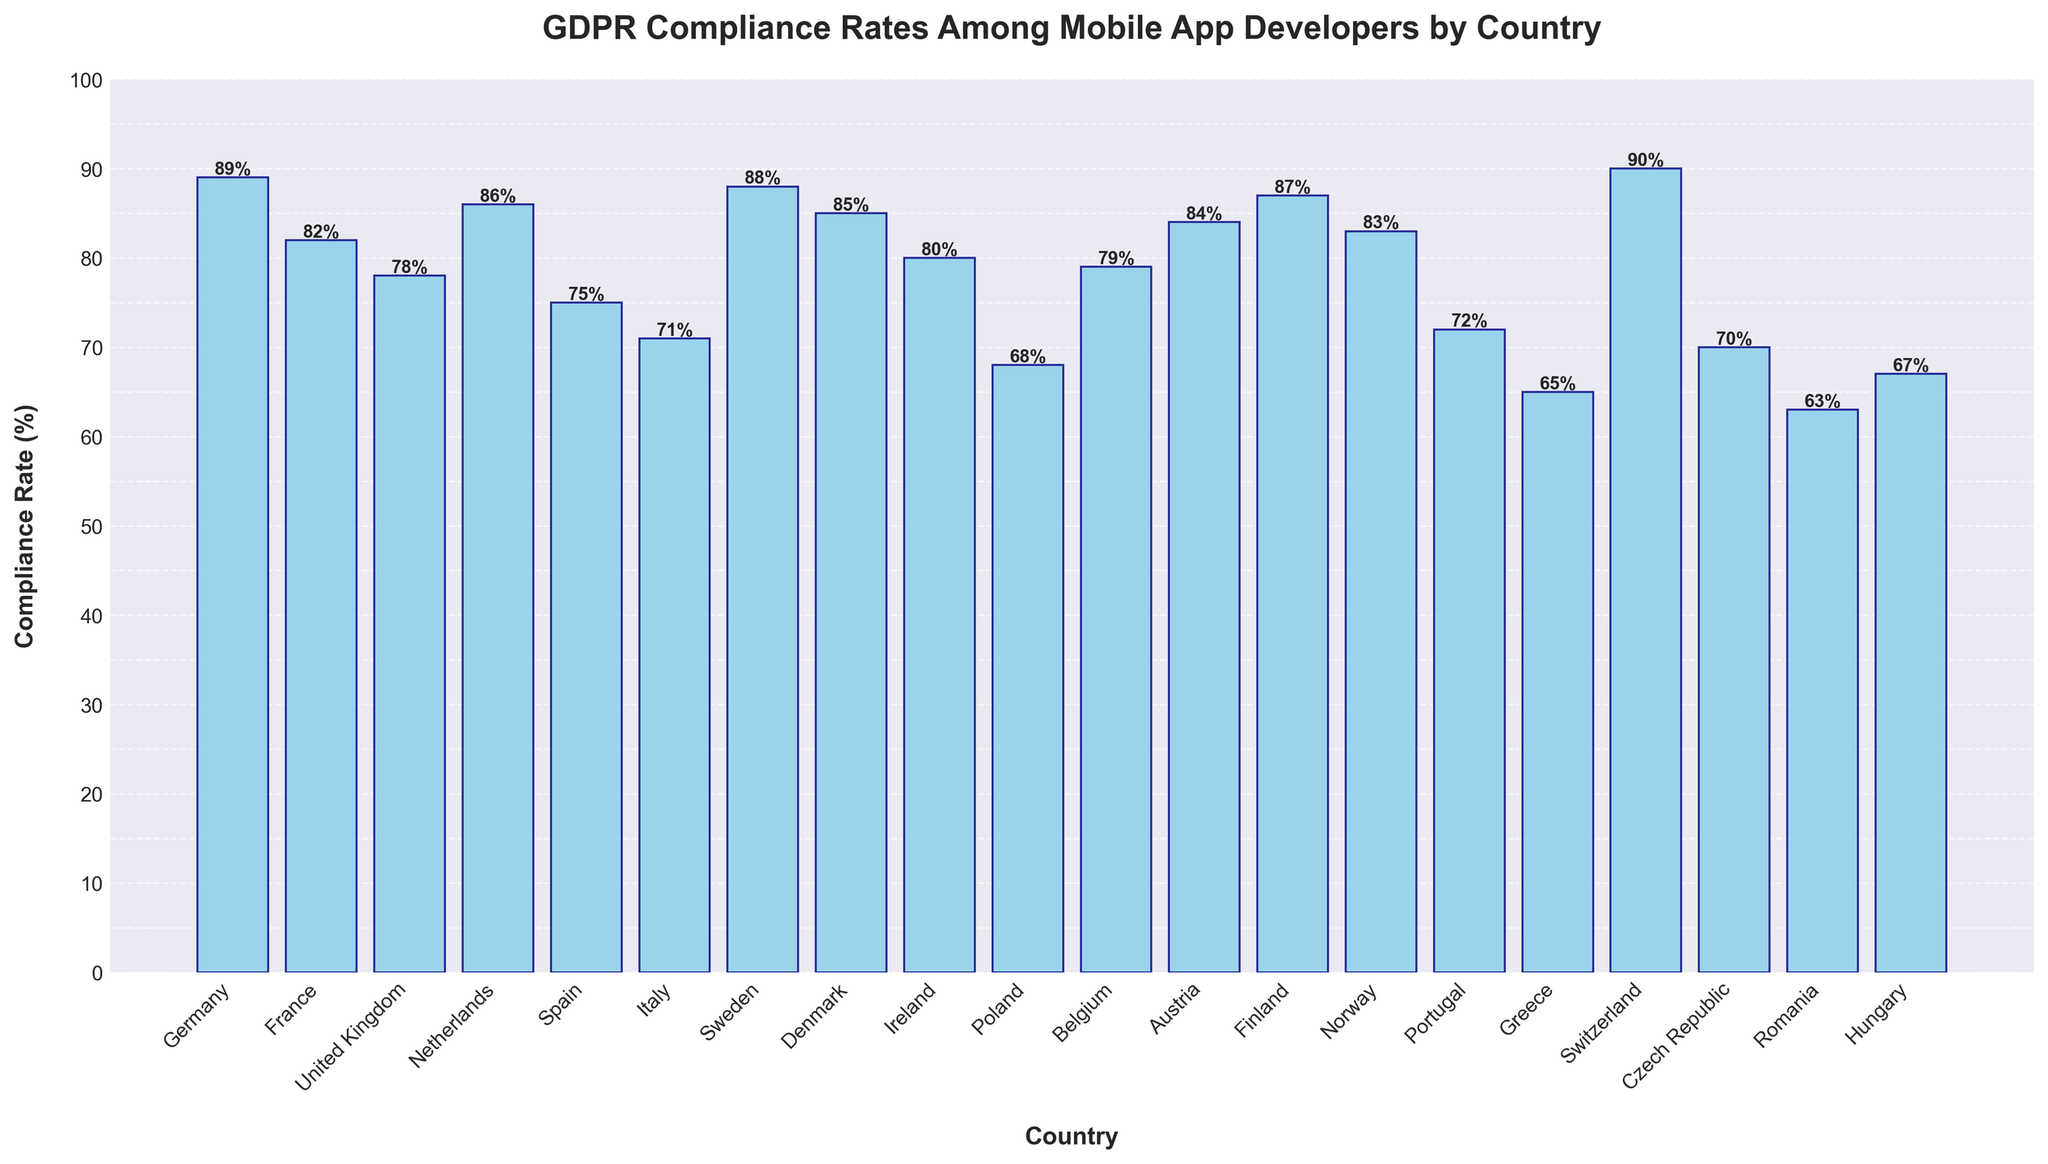What country has the highest compliance rate and what is it? Switzerland has the highest bar in the chart, indicating the highest compliance rate. The label at the top of the bar shows 90%.
Answer: Switzerland, 90% Which country has the lowest compliance rate and what is it? Romania has the shortest bar in the chart, indicating the lowest compliance rate. The label at the top of the bar shows 63%.
Answer: Romania, 63% How many countries have a compliance rate above 80%? By visually inspecting the chart and counting the bars that exceed the 80% mark, we find there are 10 such bars.
Answer: 10 Which two countries have the closest compliance rates? By comparing the heights of the bars, Sweden and Finland have nearly identical heights. The labels show compliance rates of 88% and 87%, respectively.
Answer: Sweden and Finland What is the average compliance rate for Germany, France, and the United Kingdom? Add the compliance rates for Germany (89%), France (82%), and the United Kingdom (78%). Then divide by the number of countries: (89 + 82 + 78) / 3 = 249 / 3
Answer: 83 What is the total compliance rate for the three countries with the lowest compliance? The three countries with the lowest compliance rates are Romania (63%), Greece (65%), and Poland (68%). Adding these values: 63 + 65 + 68 = 196
Answer: 196 How much higher is Germany's compliance rate compared to Italy's? Germany's compliance rate is 89%, and Italy's is 71%. The difference is 89 - 71 = 18%
Answer: 18% Which country has just a 1% higher compliance rate than Spain? Spain's compliance rate is 75%. Portugal's compliance rate is 72%, which falls short. Belgium's compliance rate is 79%, which exceeds. However, Italy's compliance rate is 71%, making it a 1% difference.
Answer: Italy How many countries have compliance rates between 70% and 80%? By visually inspecting the chart and counting the bars within the range of 70%-80% (inclusive), there are 6 bars.
Answer: 6 